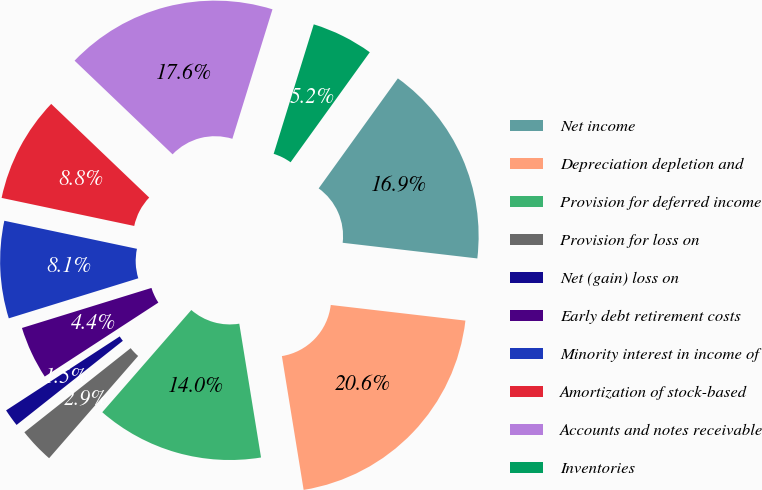<chart> <loc_0><loc_0><loc_500><loc_500><pie_chart><fcel>Net income<fcel>Depreciation depletion and<fcel>Provision for deferred income<fcel>Provision for loss on<fcel>Net (gain) loss on<fcel>Early debt retirement costs<fcel>Minority interest in income of<fcel>Amortization of stock-based<fcel>Accounts and notes receivable<fcel>Inventories<nl><fcel>16.91%<fcel>20.59%<fcel>13.97%<fcel>2.94%<fcel>1.47%<fcel>4.41%<fcel>8.09%<fcel>8.82%<fcel>17.64%<fcel>5.15%<nl></chart> 